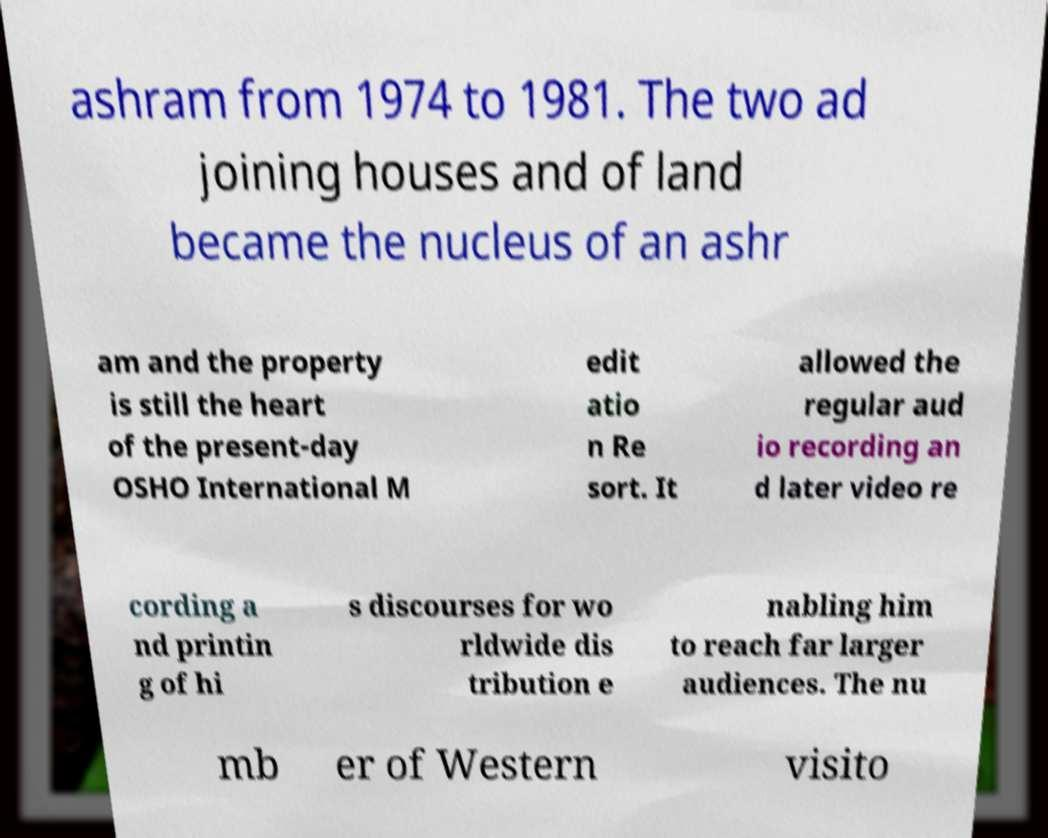There's text embedded in this image that I need extracted. Can you transcribe it verbatim? ashram from 1974 to 1981. The two ad joining houses and of land became the nucleus of an ashr am and the property is still the heart of the present-day OSHO International M edit atio n Re sort. It allowed the regular aud io recording an d later video re cording a nd printin g of hi s discourses for wo rldwide dis tribution e nabling him to reach far larger audiences. The nu mb er of Western visito 